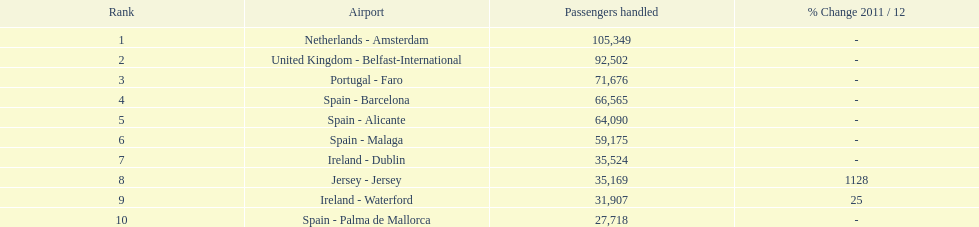Comparing the airports in the netherlands (amsterdam) and spain (palma de mallorca), what is the disparity in the volume of passengers they manage? 77,631. 